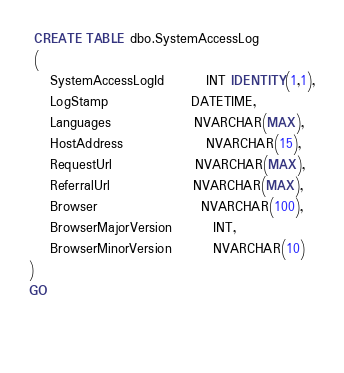Convert code to text. <code><loc_0><loc_0><loc_500><loc_500><_SQL_> CREATE TABLE dbo.SystemAccessLog
 (
	SystemAccessLogId		INT IDENTITY(1,1),
	LogStamp				DATETIME,
	Languages				NVARCHAR(MAX),
	HostAddress				NVARCHAR(15),
	RequestUrl				NVARCHAR(MAX),
	ReferralUrl				NVARCHAR(MAX),
	Browser					NVARCHAR(100),
	BrowserMajorVersion		INT,
	BrowserMinorVersion		NVARCHAR(10)
)
GO

	</code> 